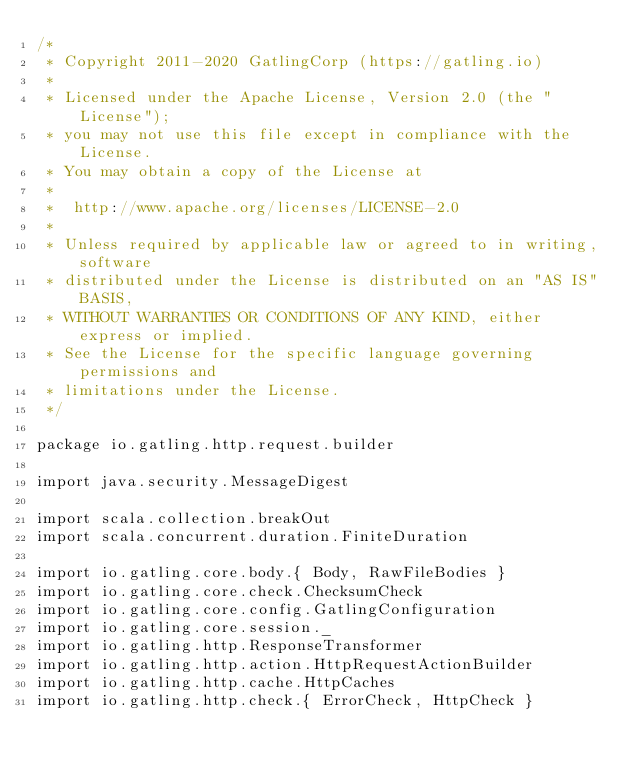Convert code to text. <code><loc_0><loc_0><loc_500><loc_500><_Scala_>/*
 * Copyright 2011-2020 GatlingCorp (https://gatling.io)
 *
 * Licensed under the Apache License, Version 2.0 (the "License");
 * you may not use this file except in compliance with the License.
 * You may obtain a copy of the License at
 *
 *  http://www.apache.org/licenses/LICENSE-2.0
 *
 * Unless required by applicable law or agreed to in writing, software
 * distributed under the License is distributed on an "AS IS" BASIS,
 * WITHOUT WARRANTIES OR CONDITIONS OF ANY KIND, either express or implied.
 * See the License for the specific language governing permissions and
 * limitations under the License.
 */

package io.gatling.http.request.builder

import java.security.MessageDigest

import scala.collection.breakOut
import scala.concurrent.duration.FiniteDuration

import io.gatling.core.body.{ Body, RawFileBodies }
import io.gatling.core.check.ChecksumCheck
import io.gatling.core.config.GatlingConfiguration
import io.gatling.core.session._
import io.gatling.http.ResponseTransformer
import io.gatling.http.action.HttpRequestActionBuilder
import io.gatling.http.cache.HttpCaches
import io.gatling.http.check.{ ErrorCheck, HttpCheck }</code> 